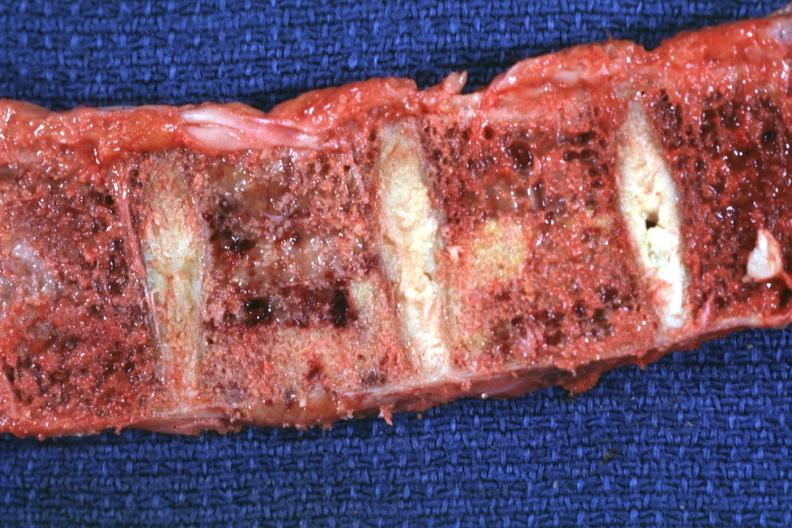what does this image show?
Answer the question using a single word or phrase. Vertebral bodies shown close-up with metastases 